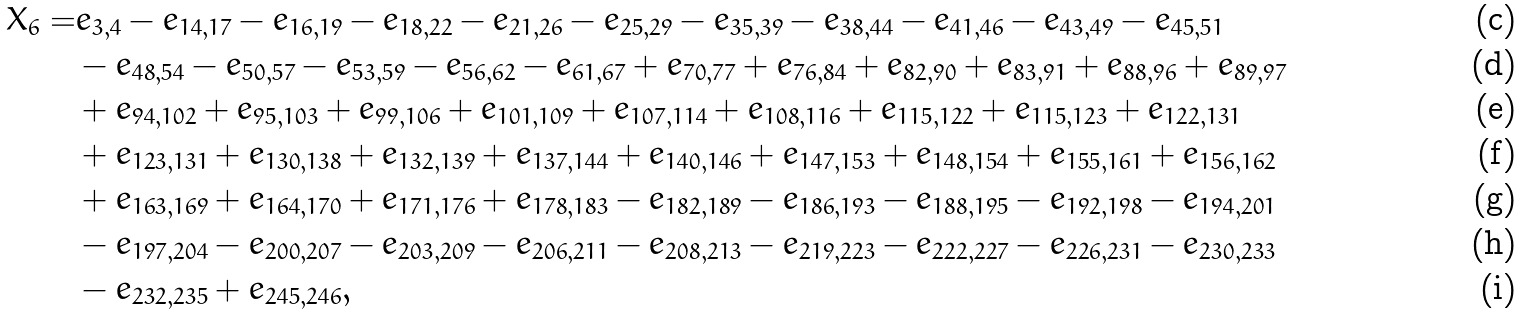<formula> <loc_0><loc_0><loc_500><loc_500>X _ { 6 } = & e _ { 3 , 4 } - e _ { 1 4 , 1 7 } - e _ { 1 6 , 1 9 } - e _ { 1 8 , 2 2 } - e _ { 2 1 , 2 6 } - e _ { 2 5 , 2 9 } - e _ { 3 5 , 3 9 } - e _ { 3 8 , 4 4 } - e _ { 4 1 , 4 6 } - e _ { 4 3 , 4 9 } - e _ { 4 5 , 5 1 } \\ & - e _ { 4 8 , 5 4 } - e _ { 5 0 , 5 7 } - e _ { 5 3 , 5 9 } - e _ { 5 6 , 6 2 } - e _ { 6 1 , 6 7 } + e _ { 7 0 , 7 7 } + e _ { 7 6 , 8 4 } + e _ { 8 2 , 9 0 } + e _ { 8 3 , 9 1 } + e _ { 8 8 , 9 6 } + e _ { 8 9 , 9 7 } \\ & + e _ { 9 4 , 1 0 2 } + e _ { 9 5 , 1 0 3 } + e _ { 9 9 , 1 0 6 } + e _ { 1 0 1 , 1 0 9 } + e _ { 1 0 7 , 1 1 4 } + e _ { 1 0 8 , 1 1 6 } + e _ { 1 1 5 , 1 2 2 } + e _ { 1 1 5 , 1 2 3 } + e _ { 1 2 2 , 1 3 1 } \\ & + e _ { 1 2 3 , 1 3 1 } + e _ { 1 3 0 , 1 3 8 } + e _ { 1 3 2 , 1 3 9 } + e _ { 1 3 7 , 1 4 4 } + e _ { 1 4 0 , 1 4 6 } + e _ { 1 4 7 , 1 5 3 } + e _ { 1 4 8 , 1 5 4 } + e _ { 1 5 5 , 1 6 1 } + e _ { 1 5 6 , 1 6 2 } \\ & + e _ { 1 6 3 , 1 6 9 } + e _ { 1 6 4 , 1 7 0 } + e _ { 1 7 1 , 1 7 6 } + e _ { 1 7 8 , 1 8 3 } - e _ { 1 8 2 , 1 8 9 } - e _ { 1 8 6 , 1 9 3 } - e _ { 1 8 8 , 1 9 5 } - e _ { 1 9 2 , 1 9 8 } - e _ { 1 9 4 , 2 0 1 } \\ & - e _ { 1 9 7 , 2 0 4 } - e _ { 2 0 0 , 2 0 7 } - e _ { 2 0 3 , 2 0 9 } - e _ { 2 0 6 , 2 1 1 } - e _ { 2 0 8 , 2 1 3 } - e _ { 2 1 9 , 2 2 3 } - e _ { 2 2 2 , 2 2 7 } - e _ { 2 2 6 , 2 3 1 } - e _ { 2 3 0 , 2 3 3 } \\ & - e _ { 2 3 2 , 2 3 5 } + e _ { 2 4 5 , 2 4 6 } ,</formula> 